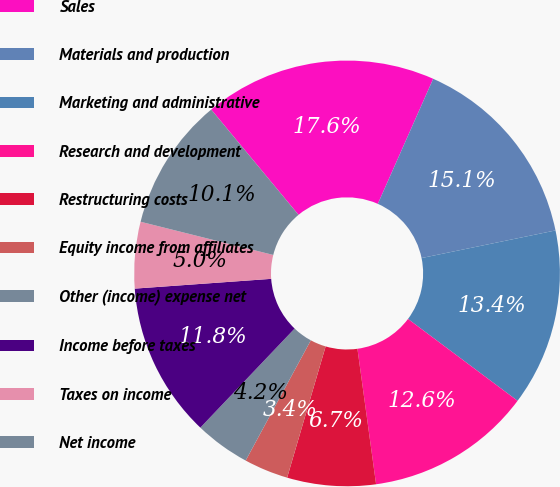<chart> <loc_0><loc_0><loc_500><loc_500><pie_chart><fcel>Sales<fcel>Materials and production<fcel>Marketing and administrative<fcel>Research and development<fcel>Restructuring costs<fcel>Equity income from affiliates<fcel>Other (income) expense net<fcel>Income before taxes<fcel>Taxes on income<fcel>Net income<nl><fcel>17.65%<fcel>15.13%<fcel>13.45%<fcel>12.61%<fcel>6.72%<fcel>3.36%<fcel>4.2%<fcel>11.76%<fcel>5.04%<fcel>10.08%<nl></chart> 